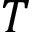<formula> <loc_0><loc_0><loc_500><loc_500>T</formula> 